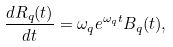<formula> <loc_0><loc_0><loc_500><loc_500>\frac { d R _ { q } ( t ) } { d t } = \omega _ { q } e ^ { \omega _ { q } t } B _ { q } ( t ) ,</formula> 